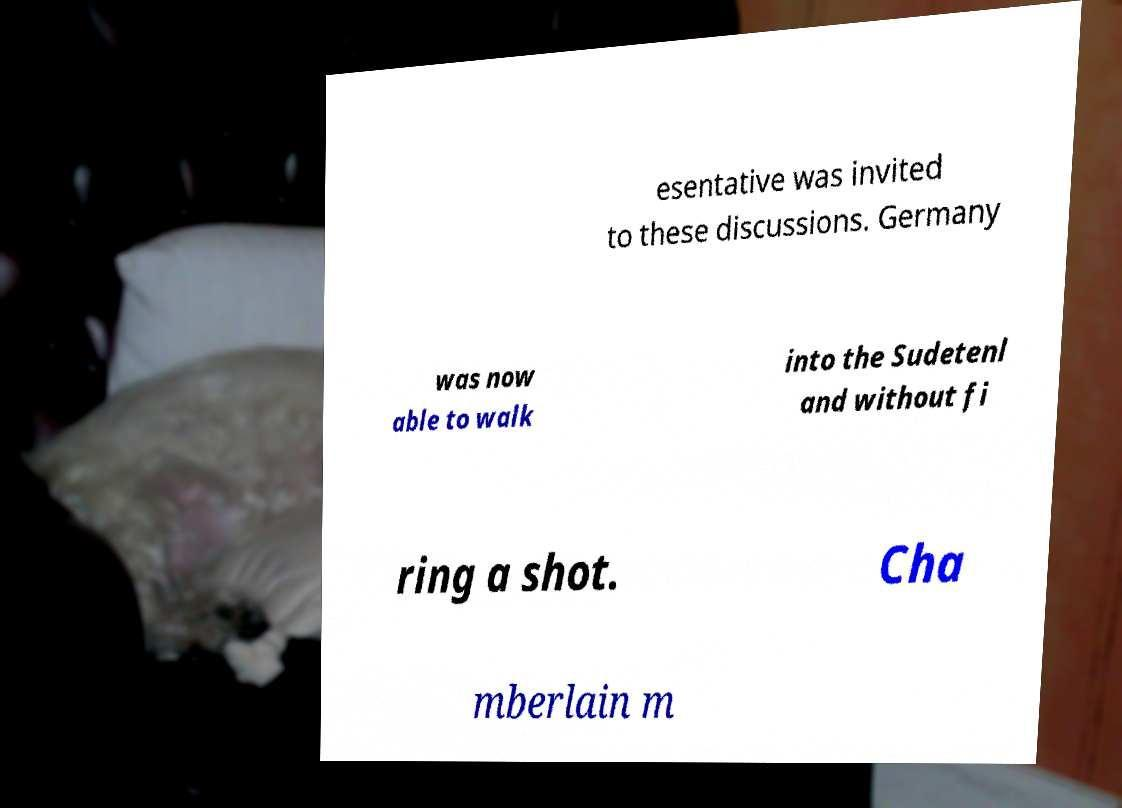Please identify and transcribe the text found in this image. esentative was invited to these discussions. Germany was now able to walk into the Sudetenl and without fi ring a shot. Cha mberlain m 